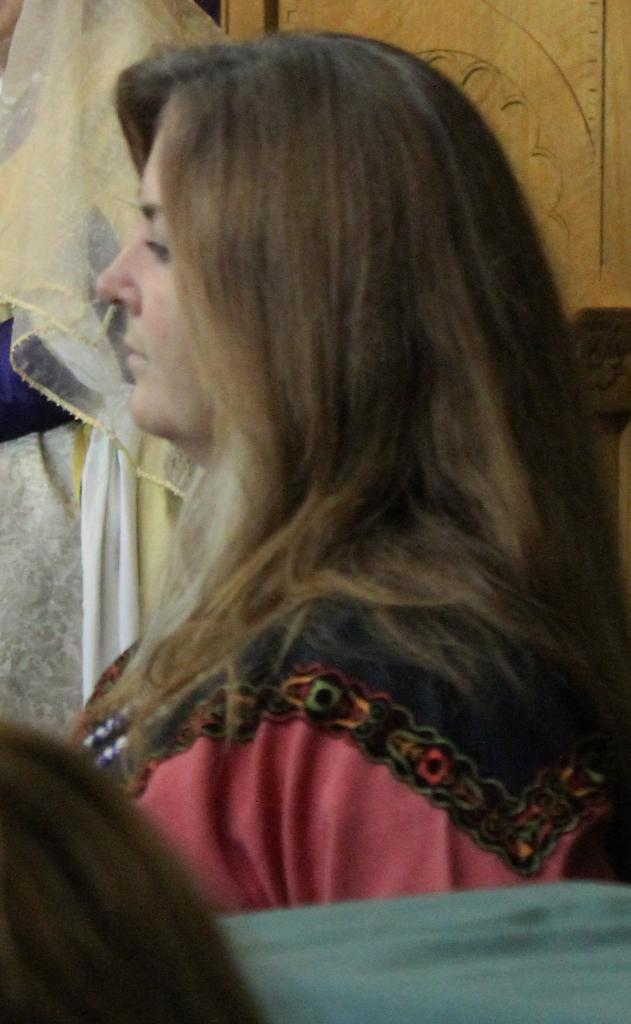Who is present in the image? There is a woman in the image. What can be seen hanging on the wall in the background of the image? There is a cloth hanging on the wall in the background of the image. What type of toothpaste is the woman using in the image? There is no toothpaste present in the image, as the facts provided do not mention any toothpaste or related activity. 